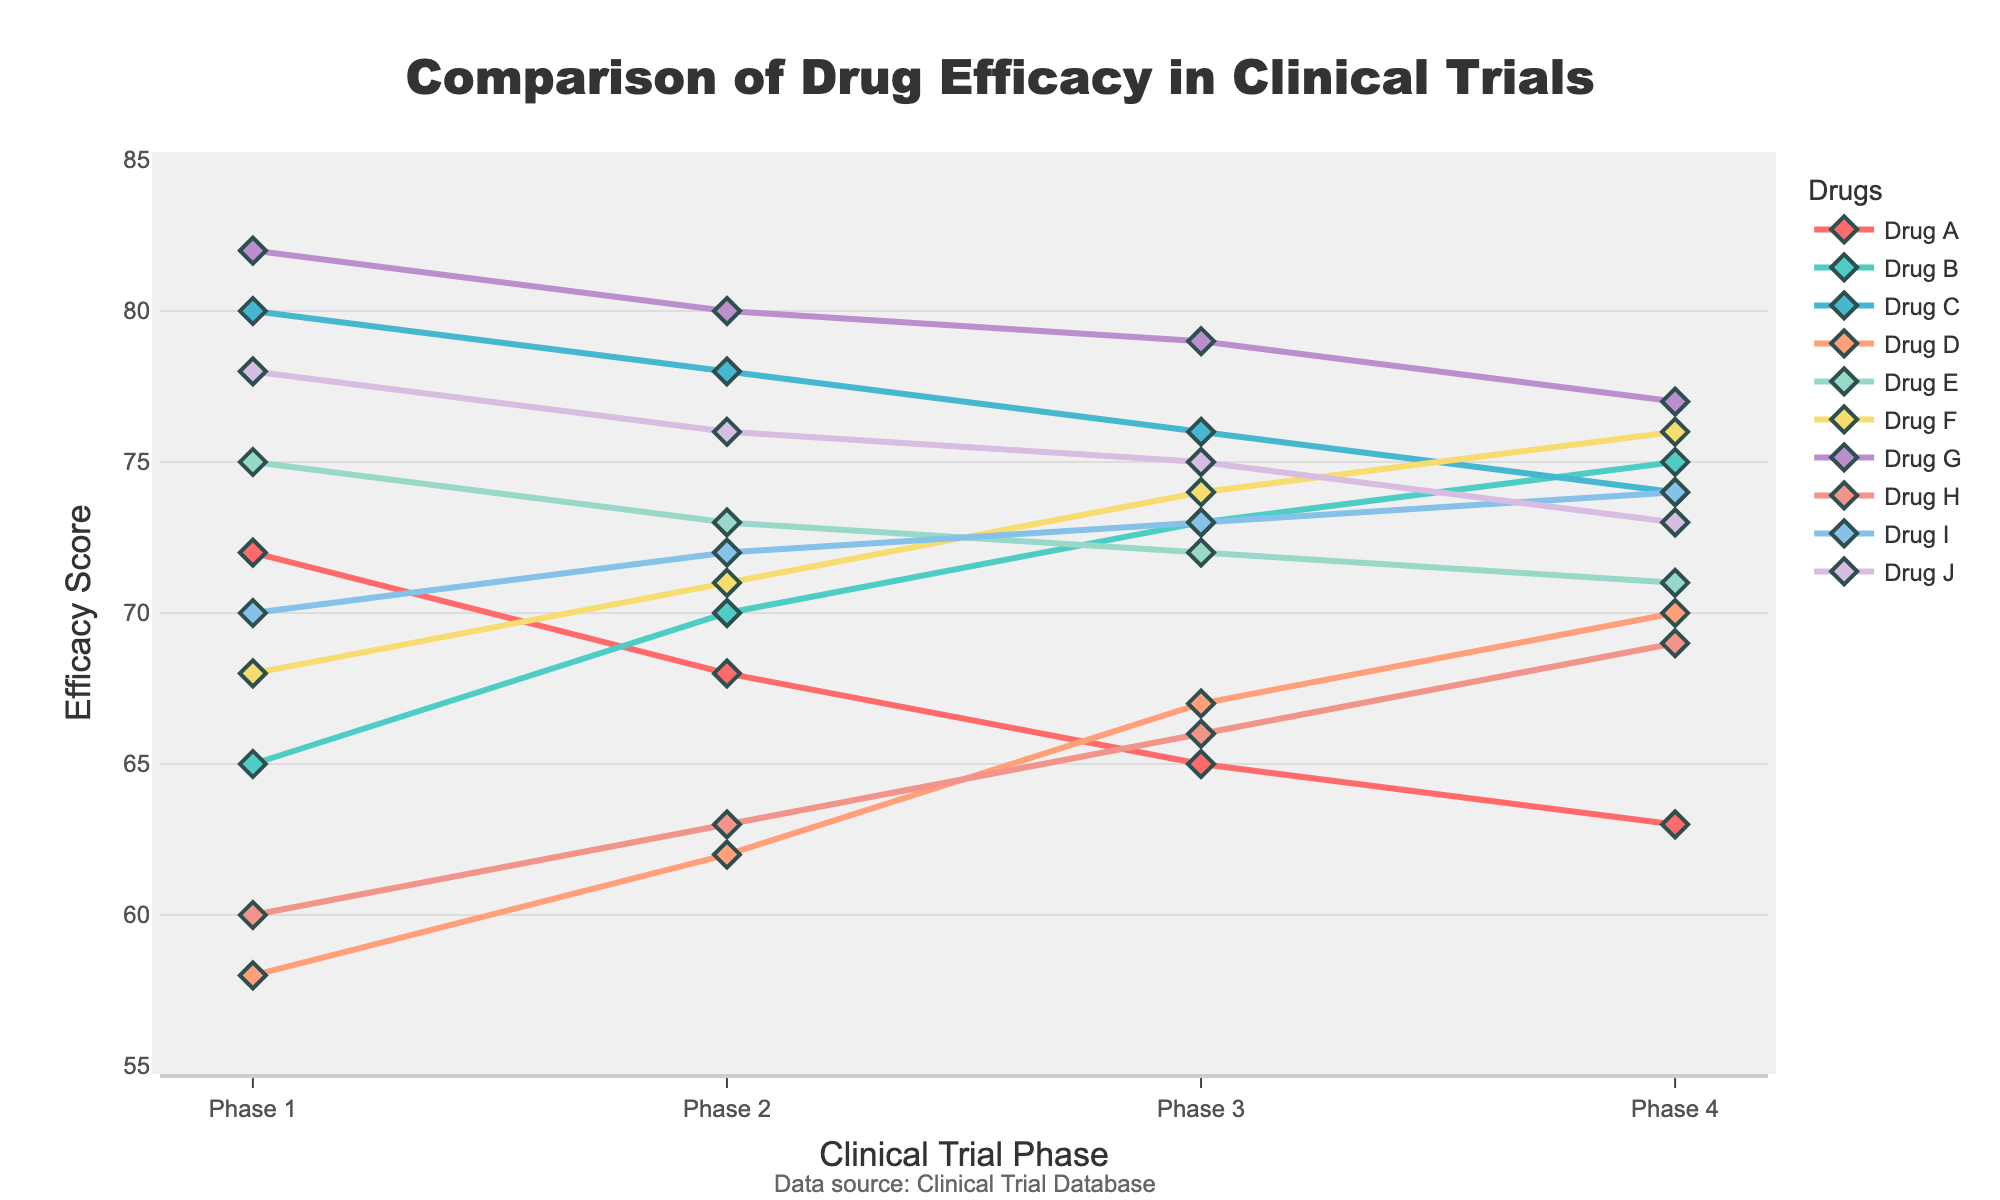Which drug shows the highest efficacy in Phase 1? In Phase 1, check the points of all drugs and identify the highest one. Drug G has the highest efficacy with a value of 82.
Answer: Drug G How does Drug A’s efficacy change from Phase 1 to Phase 4? Look at Drug A’s points in Phases 1, 2, 3, and 4. The efficacy decreases from 72 to 63.
Answer: Decreases Which drug has the lowest efficacy in Phase 2? In Phase 2, identify the lowest point among all drugs. Drug A has the lowest efficacy with a value of 68.
Answer: Drug A What is the average efficacy of Drug C across all phases? Add Drug C’s efficacy values for Phases 1, 2, 3, and 4 and divide by 4: (80 + 78 + 76 + 74) / 4 = 77.
Answer: 77 Compare the efficacy of Drug B and Drug F in Phase 3. Which one is higher? Check the values for Drug B and Drug F in Phase 3. Drug B has a value of 73, and Drug F has a value of 74. Drug F has a higher efficacy.
Answer: Drug F Which drug’s efficacy decreases the least from Phase 1 to Phase 4? Calculate the decrease for each drug from Phase 1 to Phase 4. Drug E decreases from 75 to 71 (4 points), which is the smallest decrease.
Answer: Drug E What is the total efficacy change for Drug H from Phase 1 to Phase 4? Subtract the efficacy in Phase 1 from Phase 4 for Drug H: 69 - 60 = 9.
Answer: 9 Rank the drugs based on their efficacy in Phase 4 from highest to lowest. List the efficacy values for Phase 4 and rank them: Drug F (76), Drug B (75), Drug I (74), Drug C (74), Drug G (77), Drug J (73), Drug E (71), Drug D (70), Drug H (69), Drug A (63).
Answer: Drug G, Drug F, Drug B, Drug I and Drug C, Drug J, Drug E, Drug D, Drug H, Drug A Which drug has a consistent decrease in efficacy across all phases? Identify the drugs with a steady decrease in efficacy from one phase to the next. Drugs A, C, G, and J consistently decrease in each phase.
Answer: Drugs A, C, G, J What is the difference in efficacy between Drug F and Drug D in Phase 2? Subtract Drug D’s efficacy in Phase 2 from Drug F’s efficacy in Phase 2: 71 - 62 = 9.
Answer: 9 